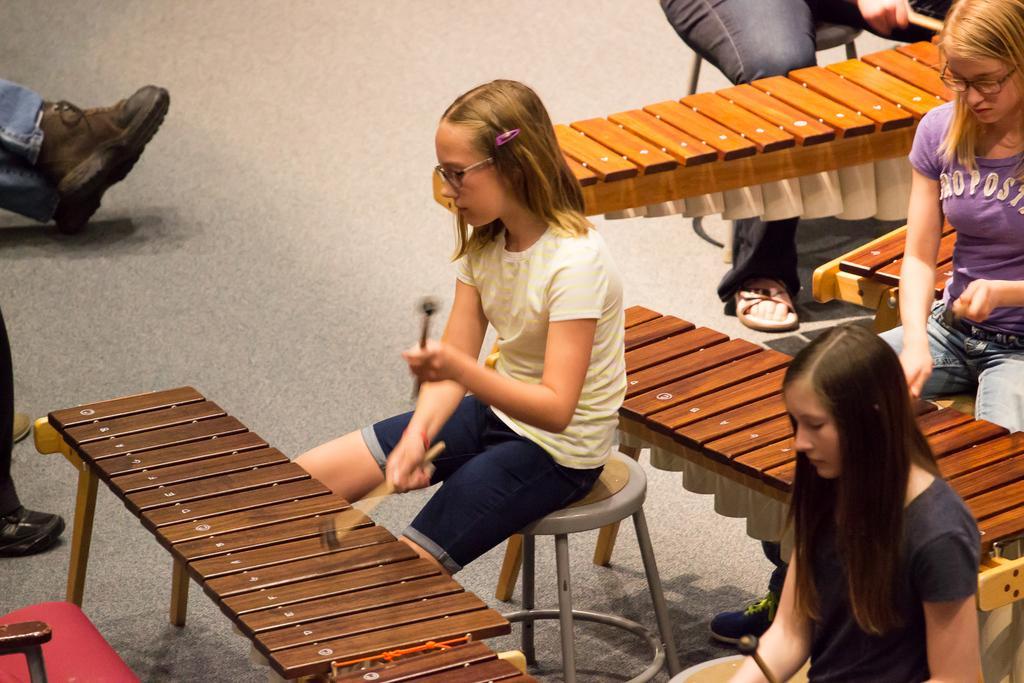In one or two sentences, can you explain what this image depicts? In this picture we can see three girls are sitting on stool and holding sticks in their hands and hitting on bench and in front of them we can see chair and some persons legs and beside to them we can see some more person also hitting with sticks. 